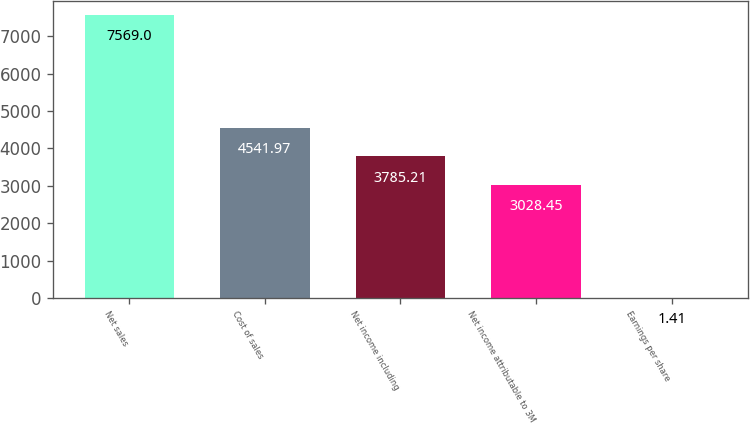Convert chart. <chart><loc_0><loc_0><loc_500><loc_500><bar_chart><fcel>Net sales<fcel>Cost of sales<fcel>Net income including<fcel>Net income attributable to 3M<fcel>Earnings per share<nl><fcel>7569<fcel>4541.97<fcel>3785.21<fcel>3028.45<fcel>1.41<nl></chart> 